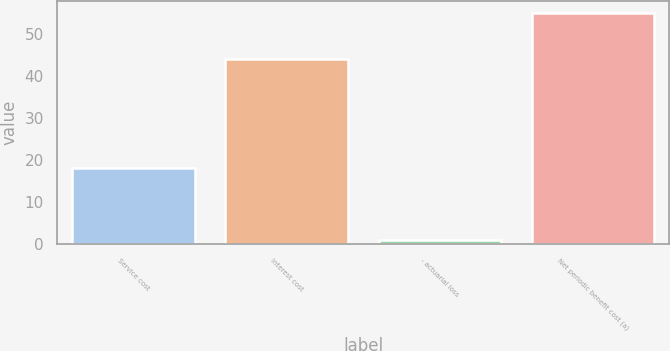Convert chart to OTSL. <chart><loc_0><loc_0><loc_500><loc_500><bar_chart><fcel>Service cost<fcel>Interest cost<fcel>- actuarial loss<fcel>Net periodic benefit cost (a)<nl><fcel>18<fcel>44<fcel>1<fcel>55<nl></chart> 